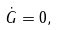<formula> <loc_0><loc_0><loc_500><loc_500>\dot { G } = 0 ,</formula> 